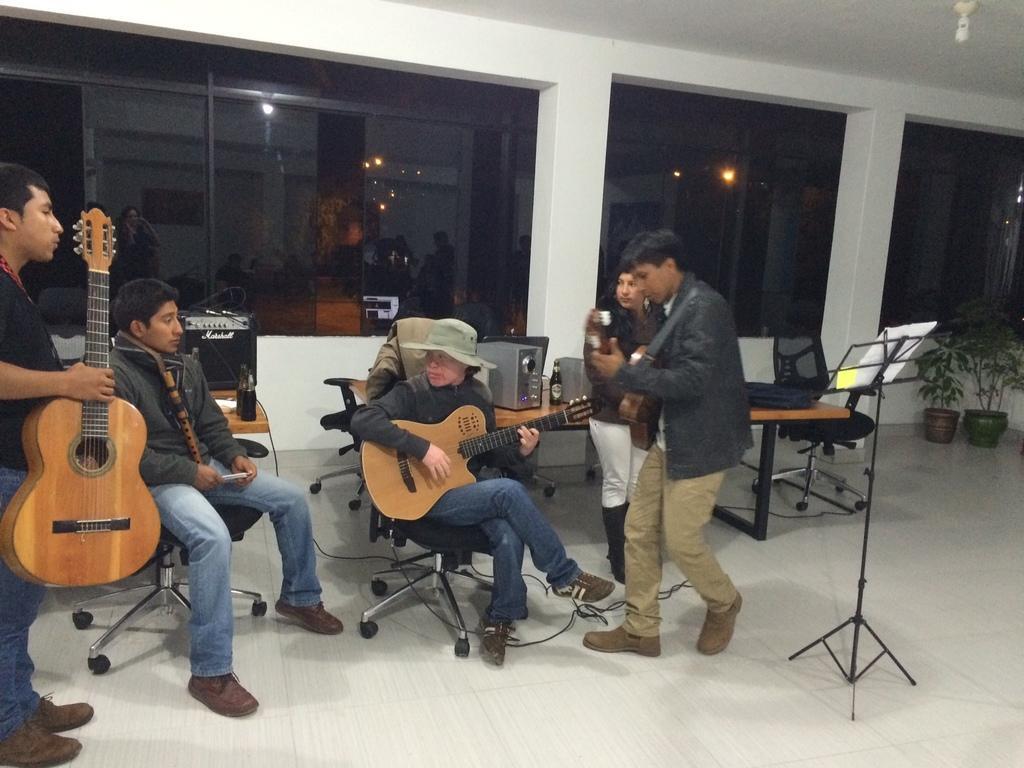How would you summarize this image in a sentence or two? This man and this woman are playing a guitar. This person is sitting on a chair. This person is holding a guitar. Far a woman is standing. In this room there are tables. On this tables there are bottles and sound box. Far there are plants. 